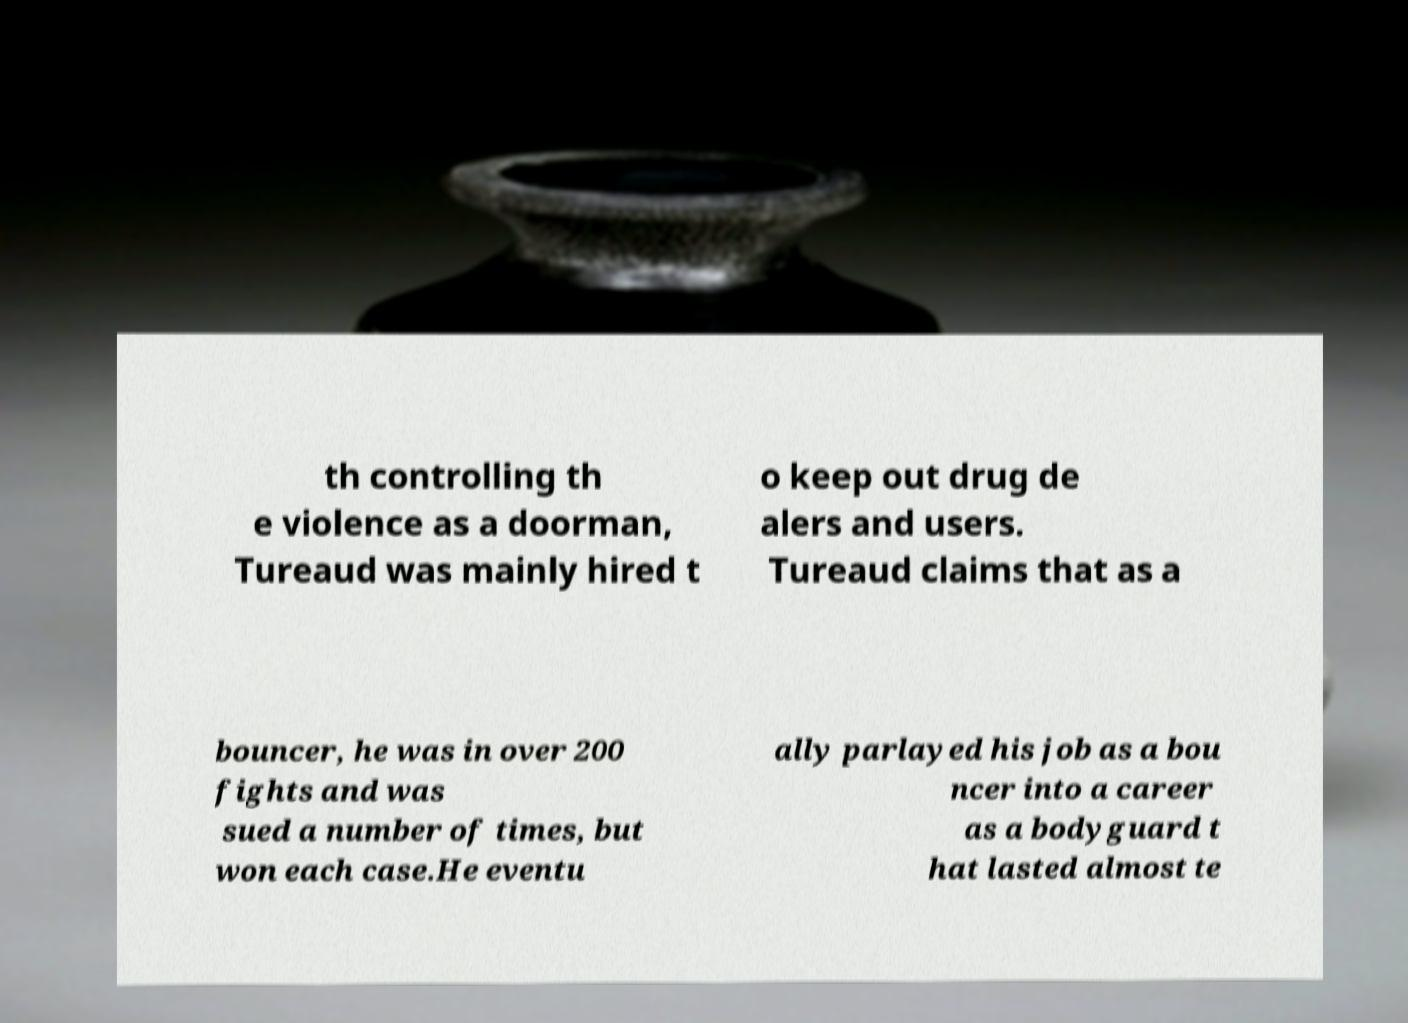Could you assist in decoding the text presented in this image and type it out clearly? th controlling th e violence as a doorman, Tureaud was mainly hired t o keep out drug de alers and users. Tureaud claims that as a bouncer, he was in over 200 fights and was sued a number of times, but won each case.He eventu ally parlayed his job as a bou ncer into a career as a bodyguard t hat lasted almost te 